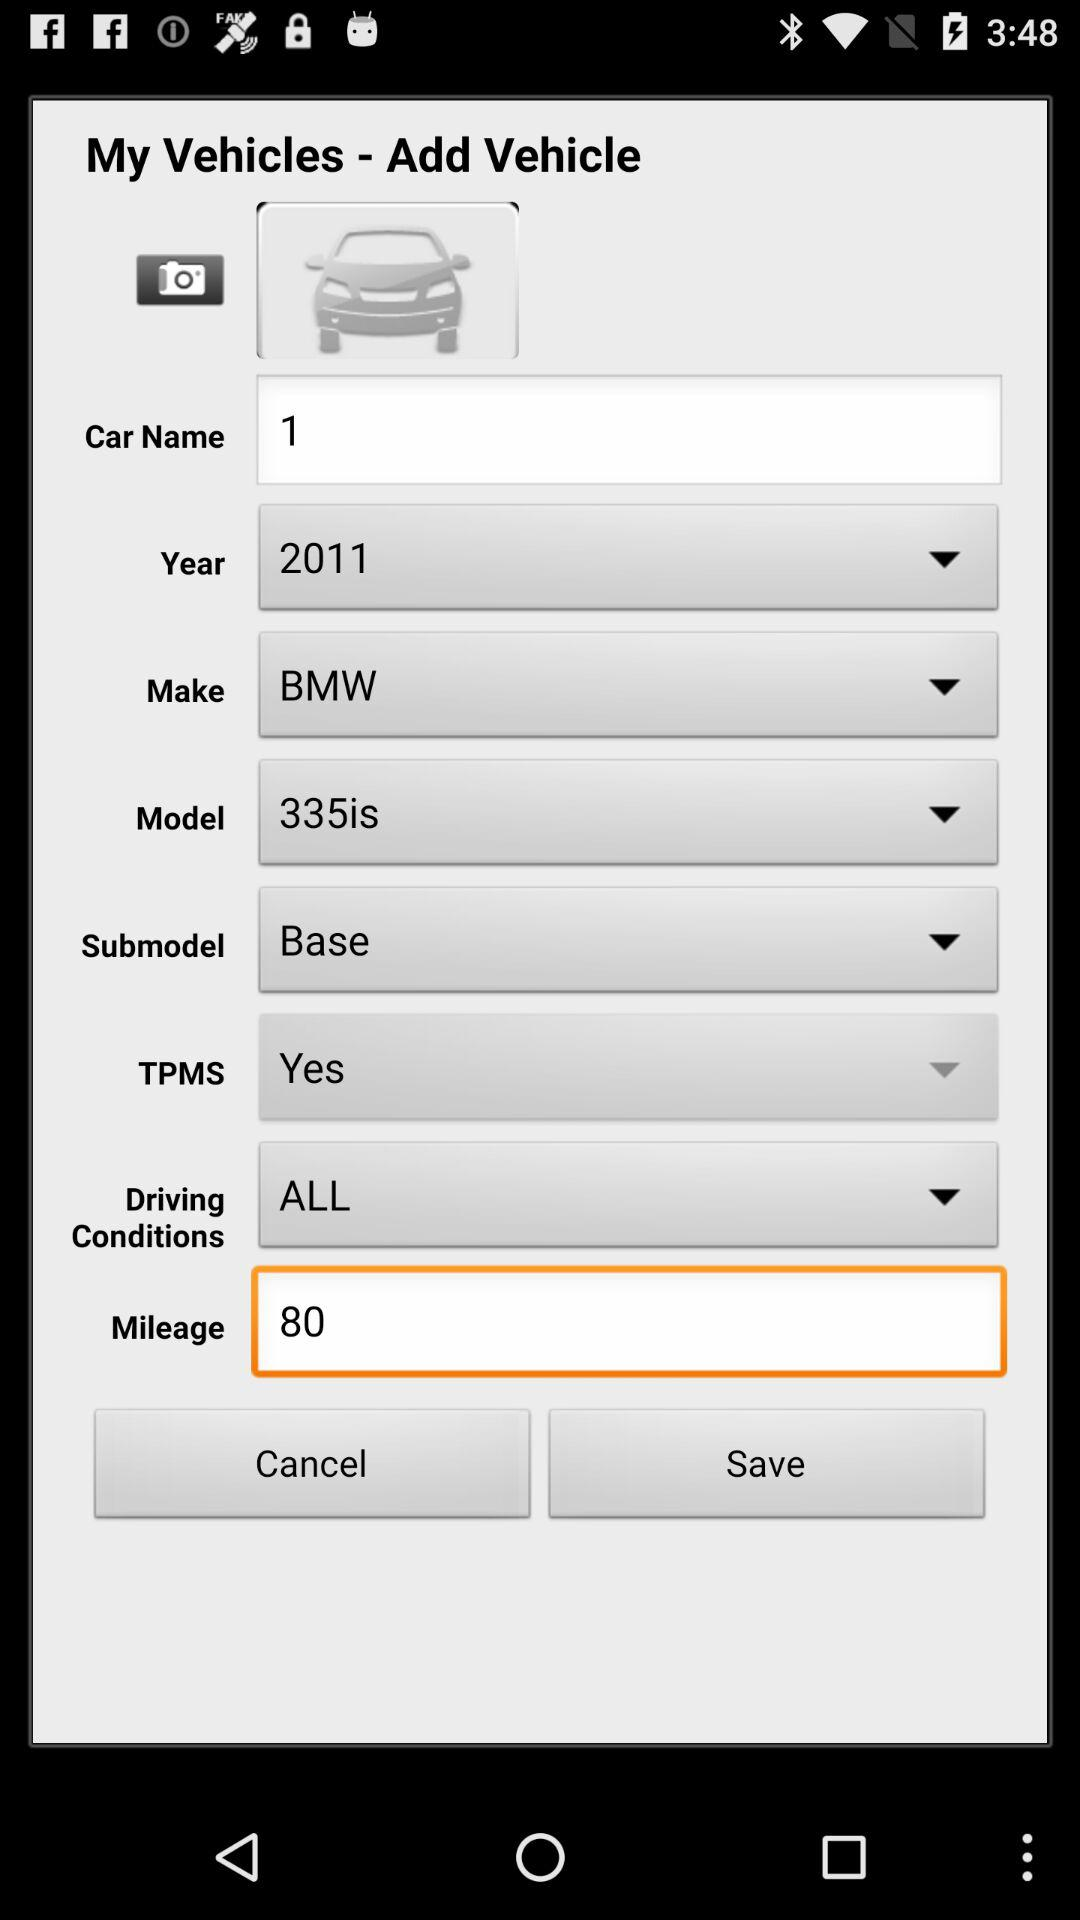What is the model of the car? The model of the car is "335is". 